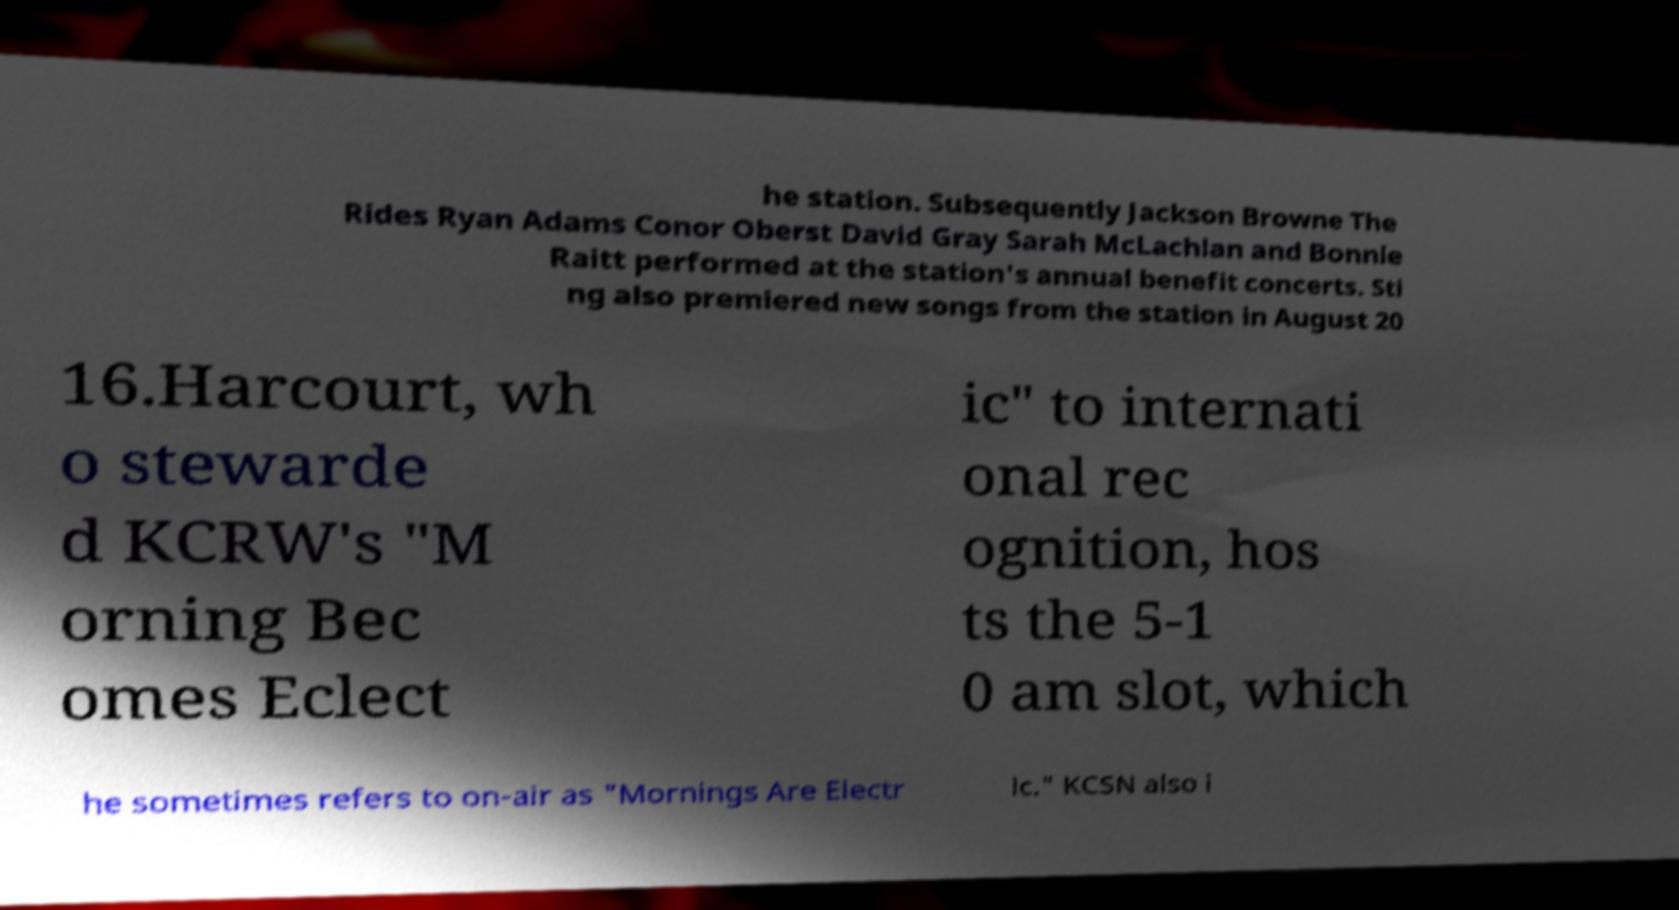I need the written content from this picture converted into text. Can you do that? he station. Subsequently Jackson Browne The Rides Ryan Adams Conor Oberst David Gray Sarah McLachlan and Bonnie Raitt performed at the station's annual benefit concerts. Sti ng also premiered new songs from the station in August 20 16.Harcourt, wh o stewarde d KCRW's "M orning Bec omes Eclect ic" to internati onal rec ognition, hos ts the 5-1 0 am slot, which he sometimes refers to on-air as "Mornings Are Electr ic." KCSN also i 